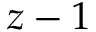Convert formula to latex. <formula><loc_0><loc_0><loc_500><loc_500>z - 1</formula> 